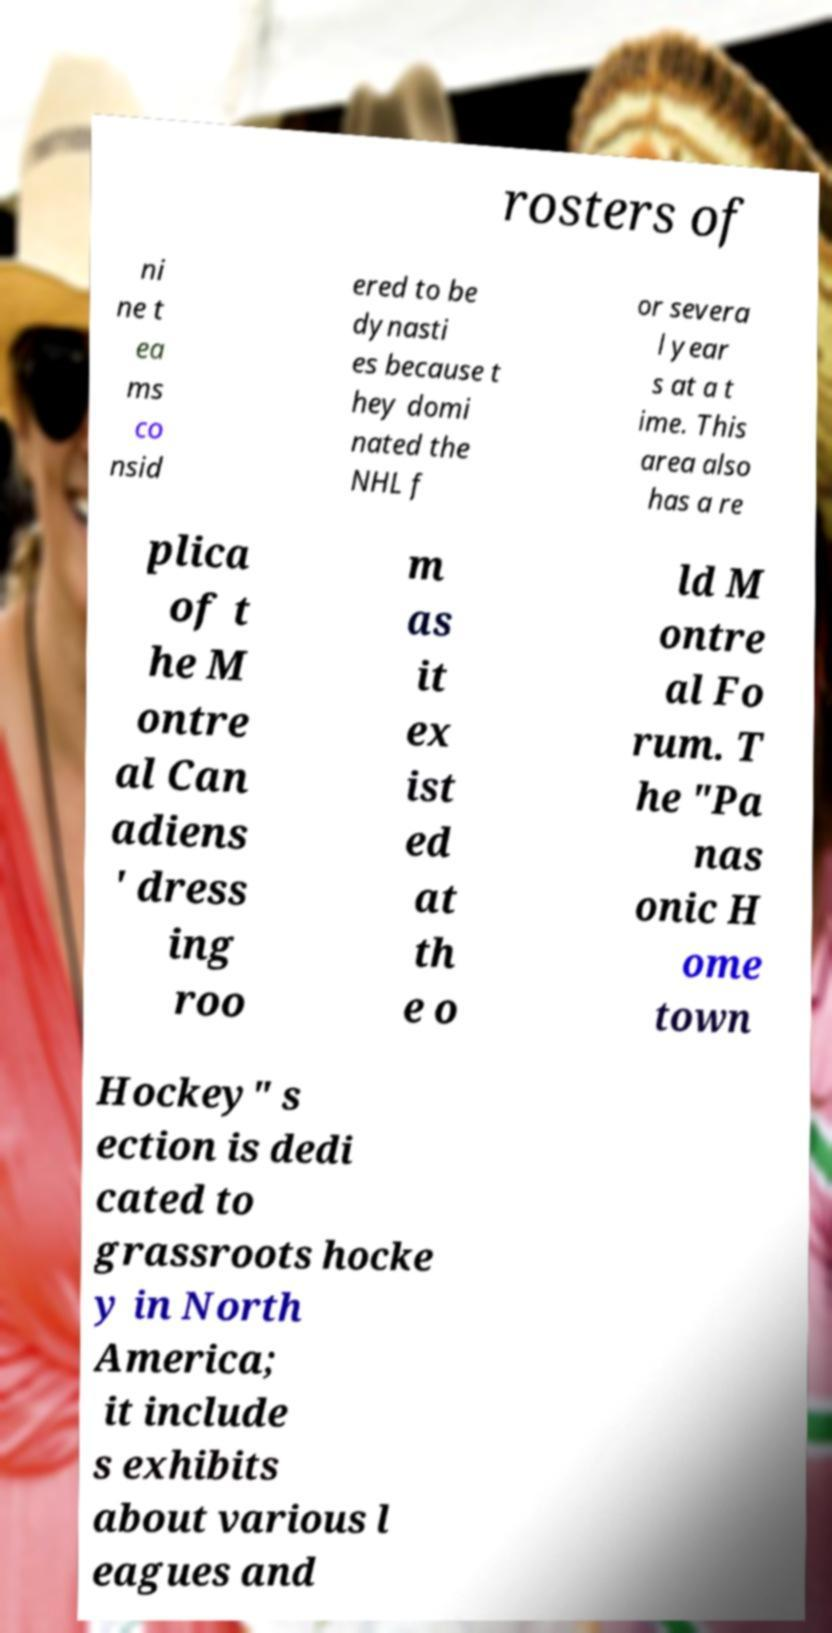For documentation purposes, I need the text within this image transcribed. Could you provide that? rosters of ni ne t ea ms co nsid ered to be dynasti es because t hey domi nated the NHL f or severa l year s at a t ime. This area also has a re plica of t he M ontre al Can adiens ' dress ing roo m as it ex ist ed at th e o ld M ontre al Fo rum. T he "Pa nas onic H ome town Hockey" s ection is dedi cated to grassroots hocke y in North America; it include s exhibits about various l eagues and 